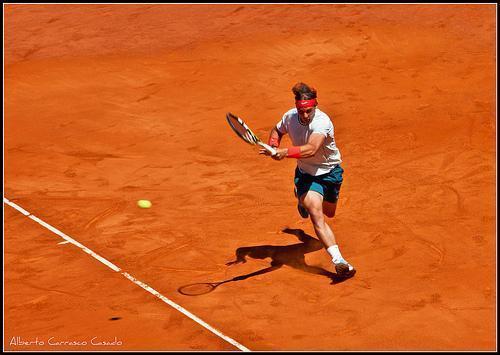How many men are there?
Give a very brief answer. 1. 